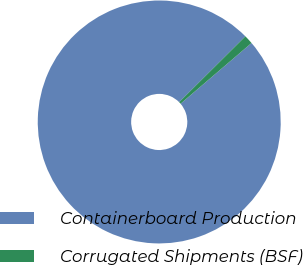Convert chart to OTSL. <chart><loc_0><loc_0><loc_500><loc_500><pie_chart><fcel>Containerboard Production<fcel>Corrugated Shipments (BSF)<nl><fcel>98.81%<fcel>1.19%<nl></chart> 